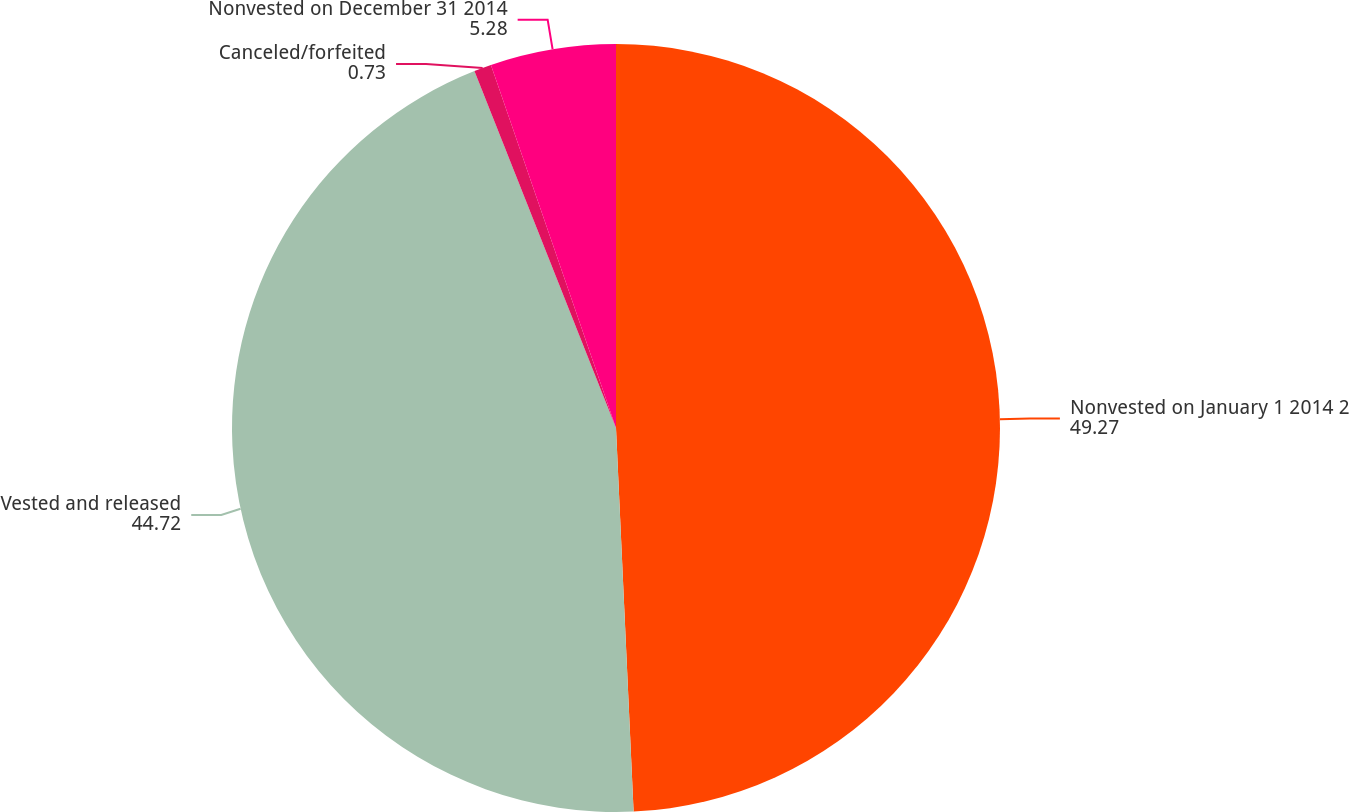<chart> <loc_0><loc_0><loc_500><loc_500><pie_chart><fcel>Nonvested on January 1 2014 2<fcel>Vested and released<fcel>Canceled/forfeited<fcel>Nonvested on December 31 2014<nl><fcel>49.27%<fcel>44.72%<fcel>0.73%<fcel>5.28%<nl></chart> 